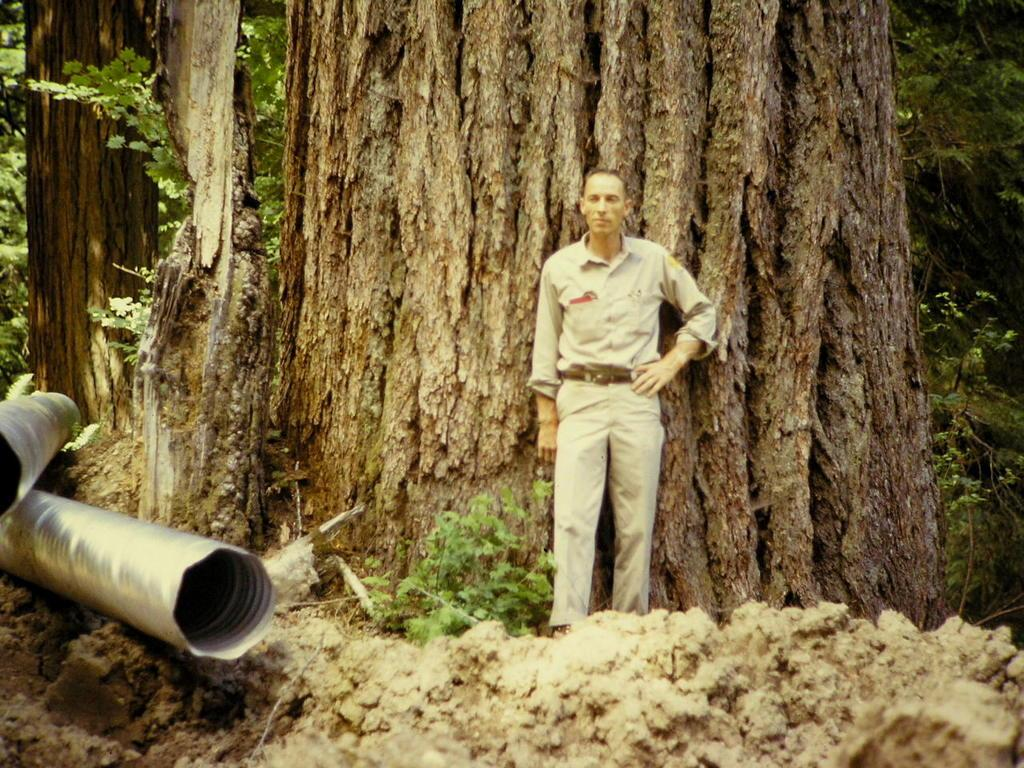What is the man in the image doing? The man is standing beside the bark of a tree in the image. What other natural elements can be seen in the image? There are plants and trees in the image. Are there any man-made structures visible in the image? Yes, there are metal poles in the image. How many girls are sitting on the metal poles in the image? There are no girls present in the image, and the metal poles are not depicted as seating. 